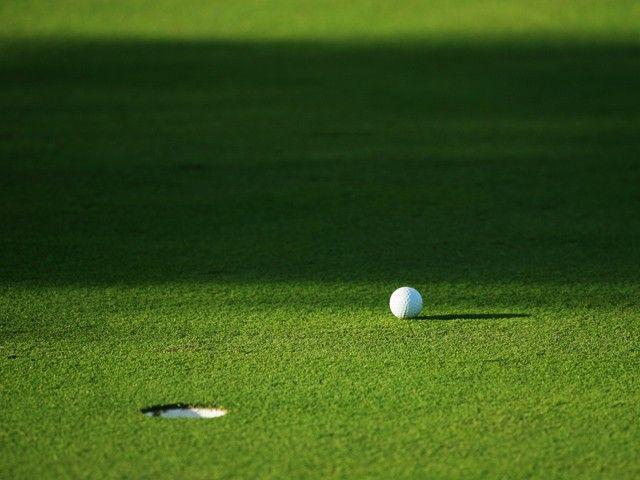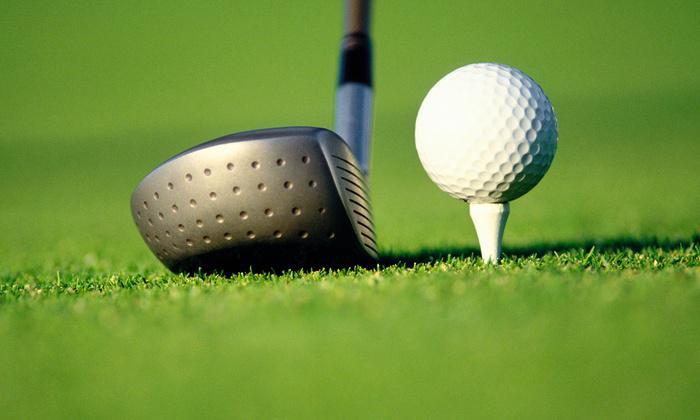The first image is the image on the left, the second image is the image on the right. For the images displayed, is the sentence "There is at least two golf balls in the left image." factually correct? Answer yes or no. No. The first image is the image on the left, the second image is the image on the right. For the images displayed, is the sentence "A golf ball is within a ball's-width of a hole with no flag in it." factually correct? Answer yes or no. No. 